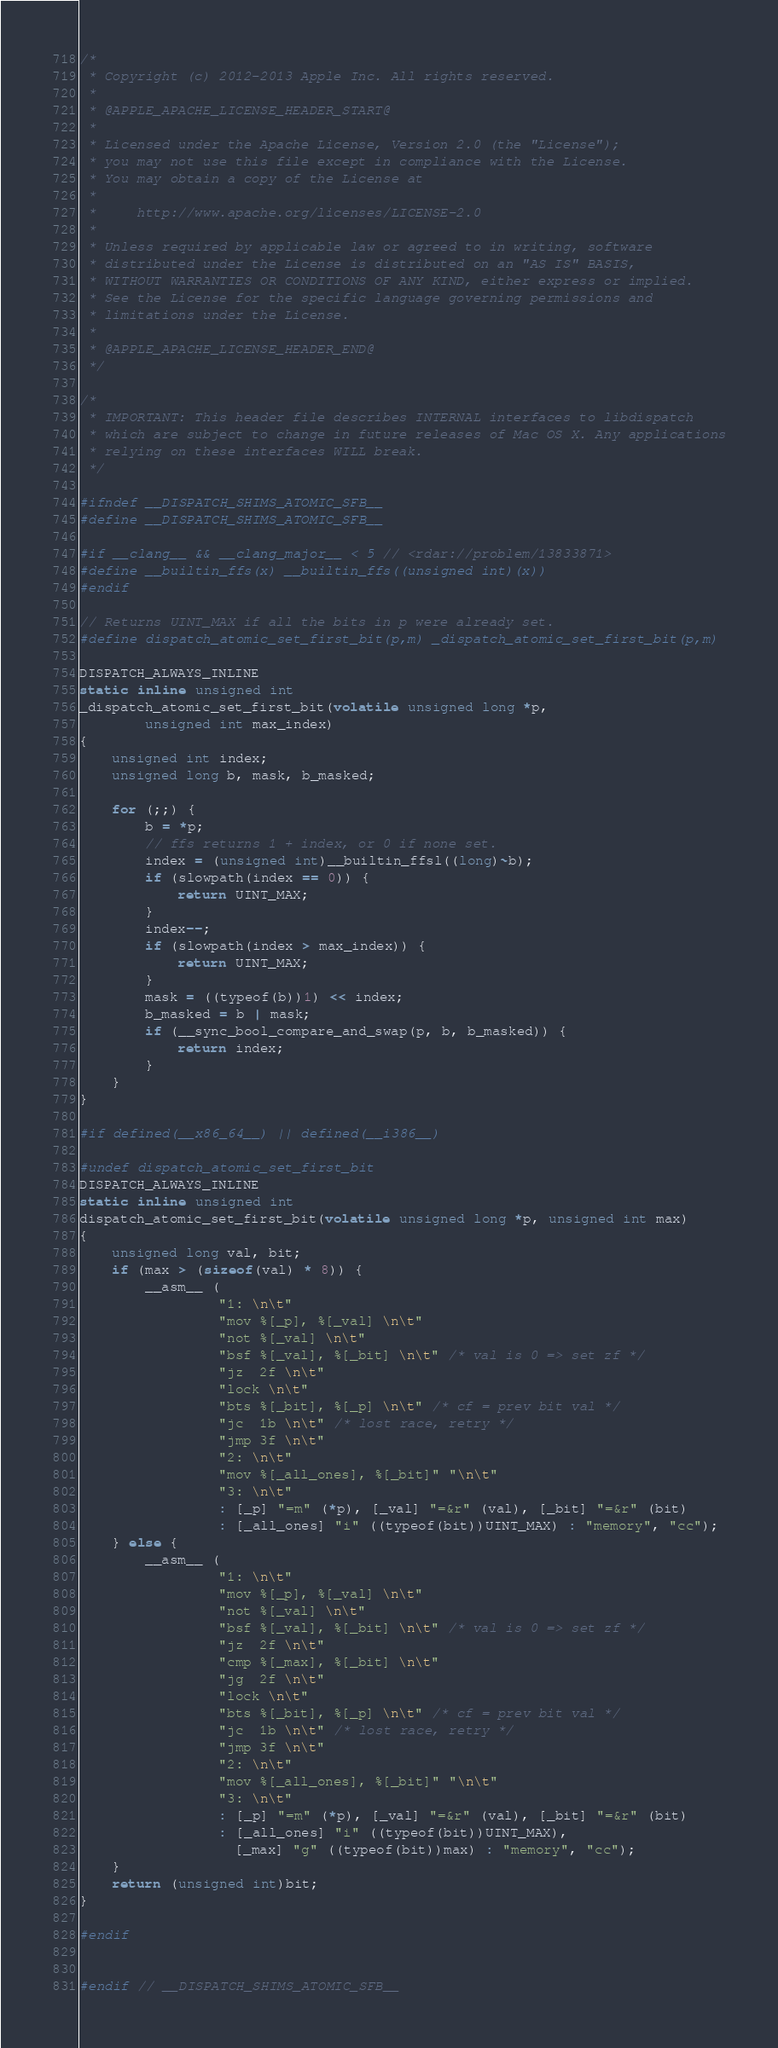<code> <loc_0><loc_0><loc_500><loc_500><_C_>/*
 * Copyright (c) 2012-2013 Apple Inc. All rights reserved.
 *
 * @APPLE_APACHE_LICENSE_HEADER_START@
 *
 * Licensed under the Apache License, Version 2.0 (the "License");
 * you may not use this file except in compliance with the License.
 * You may obtain a copy of the License at
 *
 *     http://www.apache.org/licenses/LICENSE-2.0
 *
 * Unless required by applicable law or agreed to in writing, software
 * distributed under the License is distributed on an "AS IS" BASIS,
 * WITHOUT WARRANTIES OR CONDITIONS OF ANY KIND, either express or implied.
 * See the License for the specific language governing permissions and
 * limitations under the License.
 *
 * @APPLE_APACHE_LICENSE_HEADER_END@
 */

/*
 * IMPORTANT: This header file describes INTERNAL interfaces to libdispatch
 * which are subject to change in future releases of Mac OS X. Any applications
 * relying on these interfaces WILL break.
 */

#ifndef __DISPATCH_SHIMS_ATOMIC_SFB__
#define __DISPATCH_SHIMS_ATOMIC_SFB__

#if __clang__ && __clang_major__ < 5 // <rdar://problem/13833871>
#define __builtin_ffs(x) __builtin_ffs((unsigned int)(x))
#endif

// Returns UINT_MAX if all the bits in p were already set.
#define dispatch_atomic_set_first_bit(p,m) _dispatch_atomic_set_first_bit(p,m)

DISPATCH_ALWAYS_INLINE
static inline unsigned int
_dispatch_atomic_set_first_bit(volatile unsigned long *p,
		unsigned int max_index)
{
	unsigned int index;
	unsigned long b, mask, b_masked;

	for (;;) {
		b = *p;
		// ffs returns 1 + index, or 0 if none set.
		index = (unsigned int)__builtin_ffsl((long)~b);
		if (slowpath(index == 0)) {
			return UINT_MAX;
		}
		index--;
		if (slowpath(index > max_index)) {
			return UINT_MAX;
		}
		mask = ((typeof(b))1) << index;
		b_masked = b | mask;
		if (__sync_bool_compare_and_swap(p, b, b_masked)) {
			return index;
		}
	}
}

#if defined(__x86_64__) || defined(__i386__)

#undef dispatch_atomic_set_first_bit
DISPATCH_ALWAYS_INLINE
static inline unsigned int
dispatch_atomic_set_first_bit(volatile unsigned long *p, unsigned int max)
{
	unsigned long val, bit;
	if (max > (sizeof(val) * 8)) {
		__asm__ (
				 "1: \n\t"
				 "mov	%[_p], %[_val] \n\t"
				 "not	%[_val] \n\t"
				 "bsf	%[_val], %[_bit] \n\t" /* val is 0 => set zf */
				 "jz	2f \n\t"
				 "lock \n\t"
				 "bts	%[_bit], %[_p] \n\t" /* cf = prev bit val */
				 "jc	1b \n\t" /* lost race, retry */
				 "jmp	3f \n\t"
				 "2: \n\t"
				 "mov	%[_all_ones], %[_bit]" "\n\t"
				 "3: \n\t"
				 : [_p] "=m" (*p), [_val] "=&r" (val), [_bit] "=&r" (bit)
				 : [_all_ones] "i" ((typeof(bit))UINT_MAX) : "memory", "cc");
	} else {
		__asm__ (
				 "1: \n\t"
				 "mov	%[_p], %[_val] \n\t"
				 "not	%[_val] \n\t"
				 "bsf	%[_val], %[_bit] \n\t" /* val is 0 => set zf */
				 "jz	2f \n\t"
				 "cmp	%[_max], %[_bit] \n\t"
				 "jg	2f \n\t"
				 "lock \n\t"
				 "bts	%[_bit], %[_p] \n\t" /* cf = prev bit val */
				 "jc	1b \n\t" /* lost race, retry */
				 "jmp	3f \n\t"
				 "2: \n\t"
				 "mov	%[_all_ones], %[_bit]" "\n\t"
				 "3: \n\t"
				 : [_p] "=m" (*p), [_val] "=&r" (val), [_bit] "=&r" (bit)
				 : [_all_ones] "i" ((typeof(bit))UINT_MAX),
				   [_max] "g" ((typeof(bit))max) : "memory", "cc");
	}
	return (unsigned int)bit;
}

#endif


#endif // __DISPATCH_SHIMS_ATOMIC_SFB__
</code> 